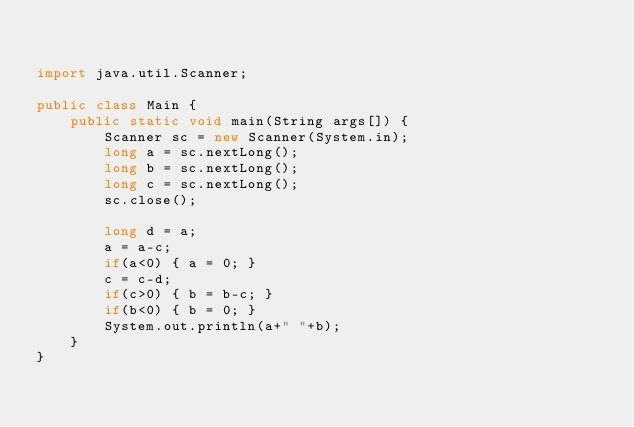<code> <loc_0><loc_0><loc_500><loc_500><_Java_>

import java.util.Scanner;

public class Main {
	public static void main(String args[]) {
		Scanner sc = new Scanner(System.in);
		long a = sc.nextLong();
		long b = sc.nextLong();
		long c = sc.nextLong();
		sc.close();

		long d = a;
		a = a-c;
		if(a<0) { a = 0; }
		c = c-d;
		if(c>0) { b = b-c; }
		if(b<0) { b = 0; }
		System.out.println(a+" "+b);
	}
}
</code> 